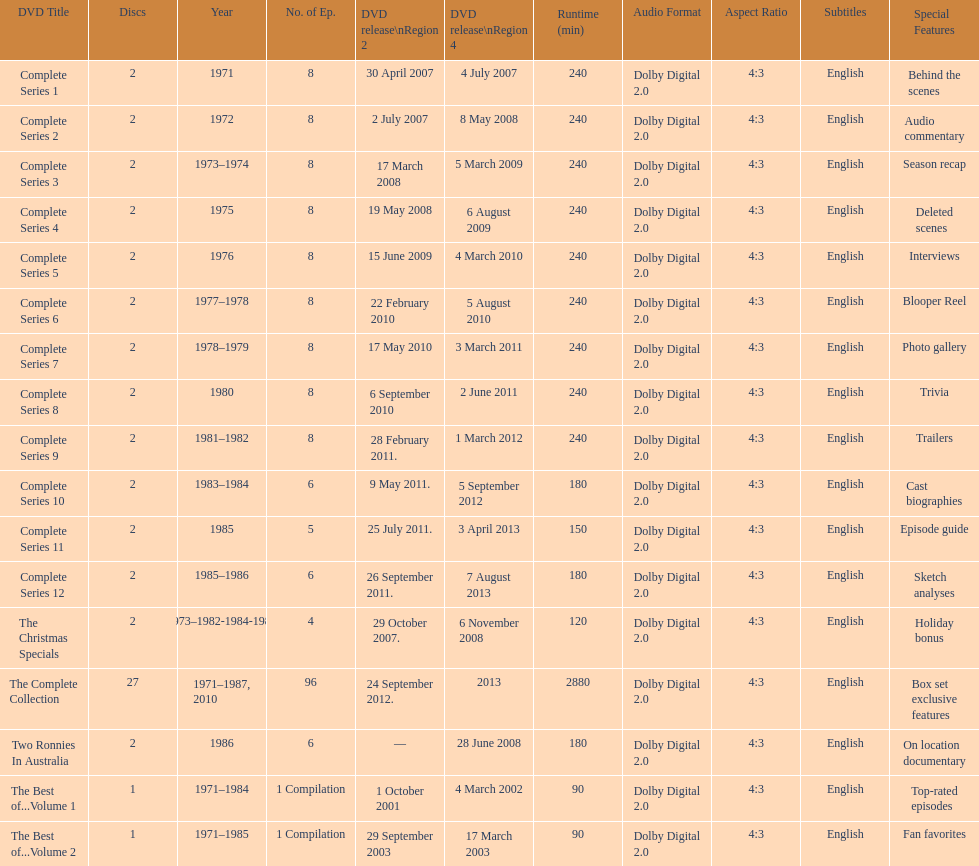What is previous to complete series 10? Complete Series 9. 